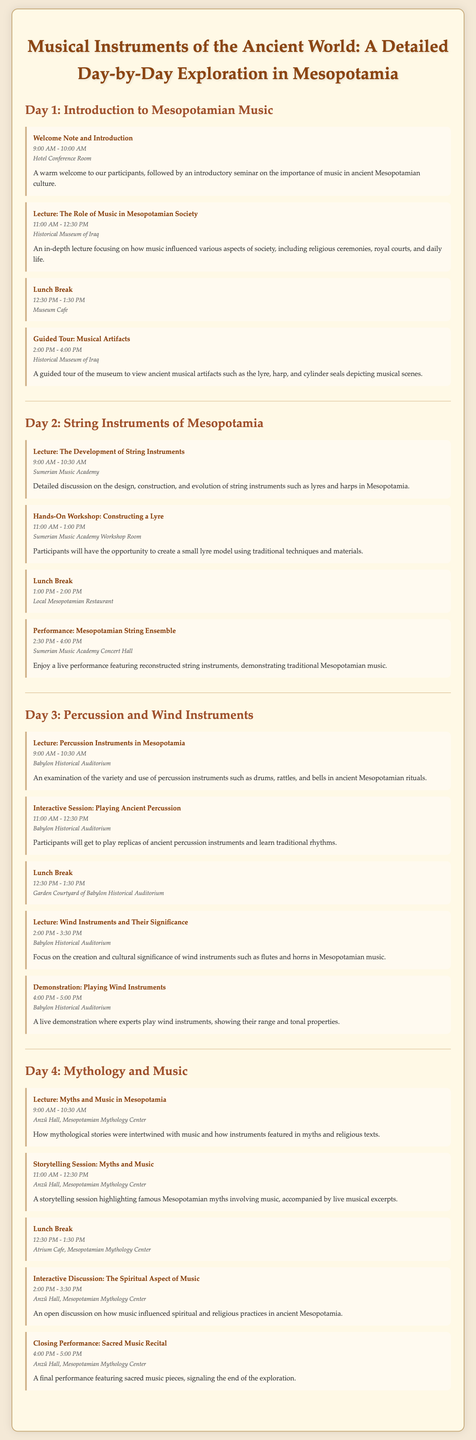what is the title of the itinerary? The title is given at the top of the document, summarizing the main theme of the exploration.
Answer: Musical Instruments of the Ancient World: A Detailed Day-by-Day Exploration in Mesopotamia how many days does the itinerary cover? The document outlines activities and information for a total of four days.
Answer: 4 days what activity is scheduled at 2:00 PM on Day 1? The document lists the activity scheduled for that time under Day 1.
Answer: Guided Tour: Musical Artifacts who will perform during the closing performance? The last activity's title indicates the nature of the performance, which involves a specific type of music.
Answer: Sacred Music Recital which location hosts the lecture on Day 3 for wind instruments? The location is specified in the document next to the relevant lecture description.
Answer: Babylon Historical Auditorium what type of instruments will participants be able to construct on Day 2? The document clearly describes the activity participants will engage in on Day 2.
Answer: Lyre what is the duration of the lunch break on Day 4? The document outlines the timing for the lunch breaks specified throughout the itinerary.
Answer: 1 hour how many activities are planned for Day 2? By counting the activities listed for Day 2 in the document, one can determine the total.
Answer: 4 activities what theme is explored on Day 4? The document presents a specific theme related to music and myth for the final day's activities.
Answer: Mythology and Music 